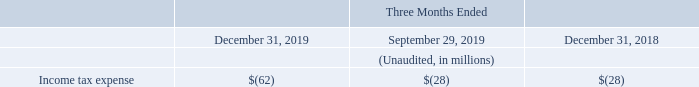During the fourth and third quarters of 2019 and the fourth quarter of 2018, we recorded an income tax expense of $62 million, $28 million and $28 million, respectively, reflecting (i) in the third quarter of 2019 the estimated annual effective tax rate in each of our jurisdictions, applied to the consolidated results before taxes in the third quarter of 2019 and (ii) in both fourth quarters the actual tax charges and benefits in each jurisdiction as well as the true-up of tax provisions based upon the most updated visibility on open tax matters in several jurisdictions. and (ii) in both fourth quarters the actual tax charges and benefits in each jurisdiction as well as the true-up of tax provisions based upon the most updated visibility on open tax matters in several jurisdictions. and (ii) in both fourth quarters the actual tax charges and benefits in each jurisdiction as well as the true-up of tax provisions based upon the most updated visibility on open tax matters in several jurisdictions.
Income tax expense
How much was the income tax expense in the fourth quarter of 2019? $62 million. What does the income tax expense in the third quarter of 2019, reflect? In the third quarter of 2019 the estimated annual effective tax rate in each of our jurisdictions, applied to the consolidated results before taxes in the third quarter of 2019. What does the income tax expense in the fourth quarter of 2018 and 2019, reflect? In both fourth quarters the actual tax charges and benefits in each jurisdiction as well as the true-up of tax provisions based upon the most updated visibility on open tax matters in several jurisdictions. What is the average Income tax expense for the period September 29, and December 31, 2019?
Answer scale should be: million. (62+28) / 2
Answer: 45. What is the average Income tax expense for the period December 31, 2019 and 2018?
Answer scale should be: million. (62+28) / 2
Answer: 45. What is the increase/ (decrease) in Income tax expense from the period December 31, 2018 to 2019?
Answer scale should be: million. 62-28
Answer: 34. 